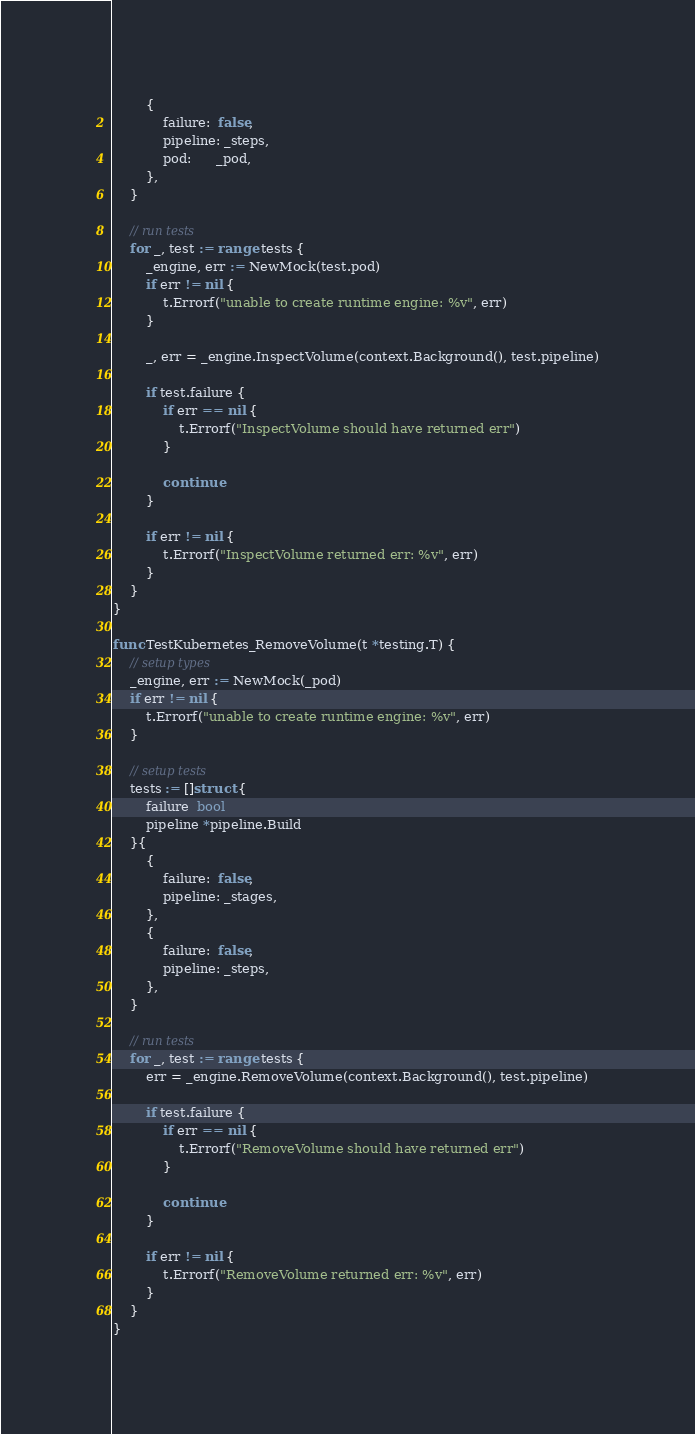Convert code to text. <code><loc_0><loc_0><loc_500><loc_500><_Go_>		{
			failure:  false,
			pipeline: _steps,
			pod:      _pod,
		},
	}

	// run tests
	for _, test := range tests {
		_engine, err := NewMock(test.pod)
		if err != nil {
			t.Errorf("unable to create runtime engine: %v", err)
		}

		_, err = _engine.InspectVolume(context.Background(), test.pipeline)

		if test.failure {
			if err == nil {
				t.Errorf("InspectVolume should have returned err")
			}

			continue
		}

		if err != nil {
			t.Errorf("InspectVolume returned err: %v", err)
		}
	}
}

func TestKubernetes_RemoveVolume(t *testing.T) {
	// setup types
	_engine, err := NewMock(_pod)
	if err != nil {
		t.Errorf("unable to create runtime engine: %v", err)
	}

	// setup tests
	tests := []struct {
		failure  bool
		pipeline *pipeline.Build
	}{
		{
			failure:  false,
			pipeline: _stages,
		},
		{
			failure:  false,
			pipeline: _steps,
		},
	}

	// run tests
	for _, test := range tests {
		err = _engine.RemoveVolume(context.Background(), test.pipeline)

		if test.failure {
			if err == nil {
				t.Errorf("RemoveVolume should have returned err")
			}

			continue
		}

		if err != nil {
			t.Errorf("RemoveVolume returned err: %v", err)
		}
	}
}
</code> 